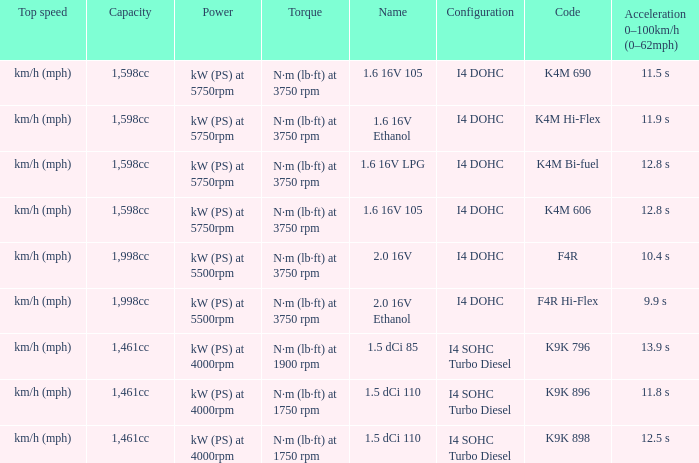What is the capacity of code f4r? 1,998cc. 